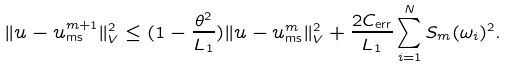<formula> <loc_0><loc_0><loc_500><loc_500>\| u - u _ { \text {ms} } ^ { m + 1 } \| _ { V } ^ { 2 } \leq ( 1 - \frac { \theta ^ { 2 } } { L _ { 1 } } ) \| u - u _ { \text {ms} } ^ { m } \| _ { V } ^ { 2 } + \frac { 2 C _ { \text {err} } } { L _ { 1 } } \sum _ { i = 1 } ^ { N } S _ { m } ( \omega _ { i } ) ^ { 2 } .</formula> 